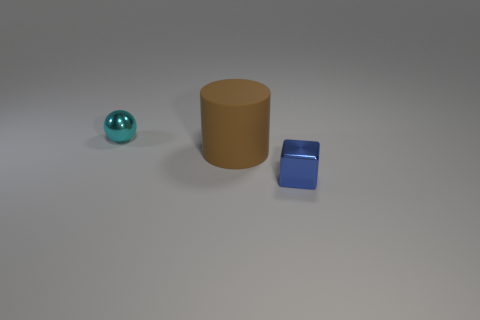Is there anything else that is the same material as the large thing?
Make the answer very short. No. How many other things are there of the same material as the tiny blue object?
Ensure brevity in your answer.  1. The large rubber cylinder is what color?
Offer a terse response. Brown. How many other brown rubber things have the same shape as the large brown matte thing?
Give a very brief answer. 0. How many objects are either tiny blue things or things that are on the left side of the metallic cube?
Offer a terse response. 3. There is a big rubber object; is its color the same as the thing that is left of the large cylinder?
Provide a short and direct response. No. What is the size of the thing that is behind the blue block and in front of the small cyan metal thing?
Make the answer very short. Large. There is a blue object; are there any large rubber things in front of it?
Ensure brevity in your answer.  No. Are there any things that are left of the small shiny object that is in front of the cylinder?
Your answer should be compact. Yes. Is the number of tiny blue metallic objects to the left of the ball the same as the number of things that are to the right of the brown object?
Make the answer very short. No. 